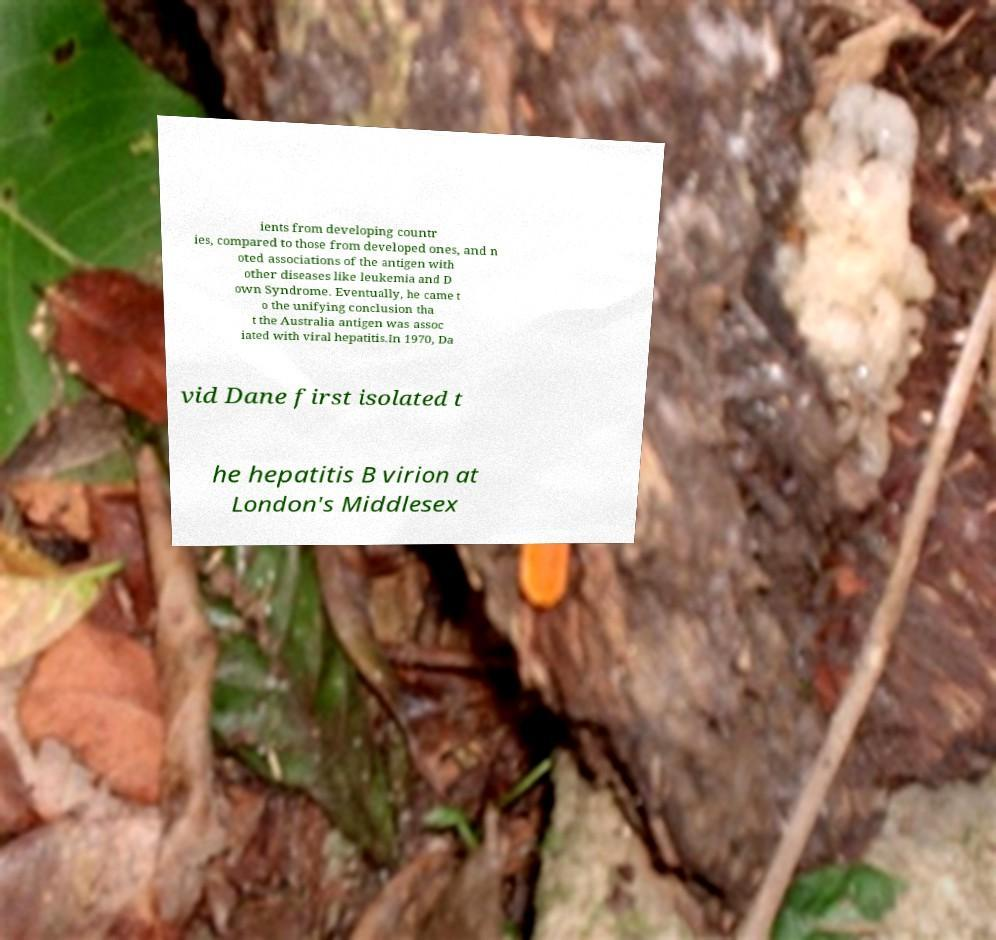For documentation purposes, I need the text within this image transcribed. Could you provide that? ients from developing countr ies, compared to those from developed ones, and n oted associations of the antigen with other diseases like leukemia and D own Syndrome. Eventually, he came t o the unifying conclusion tha t the Australia antigen was assoc iated with viral hepatitis.In 1970, Da vid Dane first isolated t he hepatitis B virion at London's Middlesex 